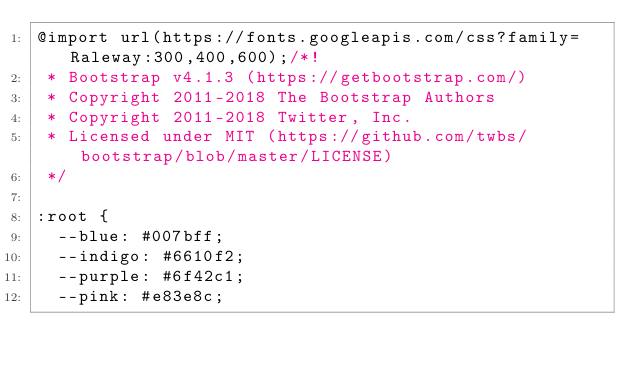<code> <loc_0><loc_0><loc_500><loc_500><_CSS_>@import url(https://fonts.googleapis.com/css?family=Raleway:300,400,600);/*!
 * Bootstrap v4.1.3 (https://getbootstrap.com/)
 * Copyright 2011-2018 The Bootstrap Authors
 * Copyright 2011-2018 Twitter, Inc.
 * Licensed under MIT (https://github.com/twbs/bootstrap/blob/master/LICENSE)
 */

:root {
  --blue: #007bff;
  --indigo: #6610f2;
  --purple: #6f42c1;
  --pink: #e83e8c;</code> 